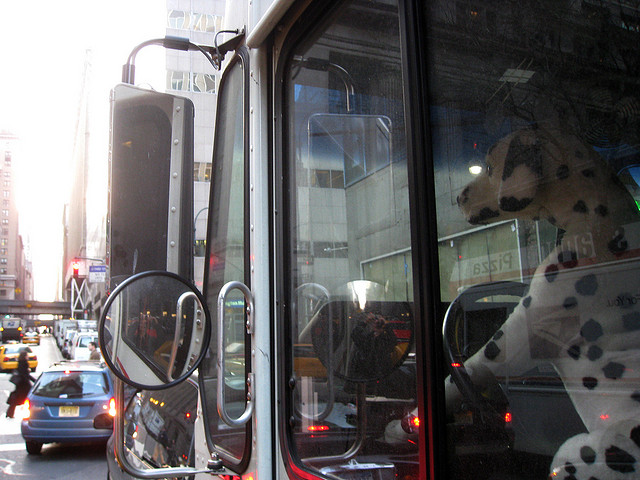Please extract the text content from this image. Pizza 